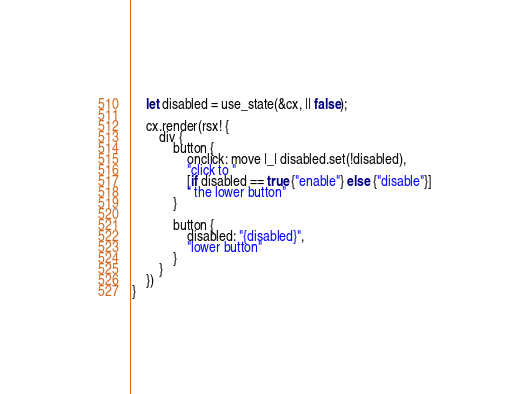Convert code to text. <code><loc_0><loc_0><loc_500><loc_500><_Rust_>    let disabled = use_state(&cx, || false);

    cx.render(rsx! {
        div {
            button {
                onclick: move |_| disabled.set(!disabled),
                "click to "
                [if disabled == true {"enable"} else {"disable"}]
                " the lower button"
            }

            button {
                disabled: "{disabled}",
                "lower button"
            }
        }
    })
}
</code> 